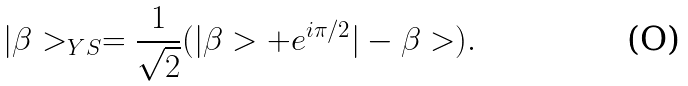<formula> <loc_0><loc_0><loc_500><loc_500>| \beta > _ { Y S } = \frac { 1 } { \sqrt { 2 } } ( | \beta > + e ^ { i \pi / 2 } | - \beta > ) .</formula> 